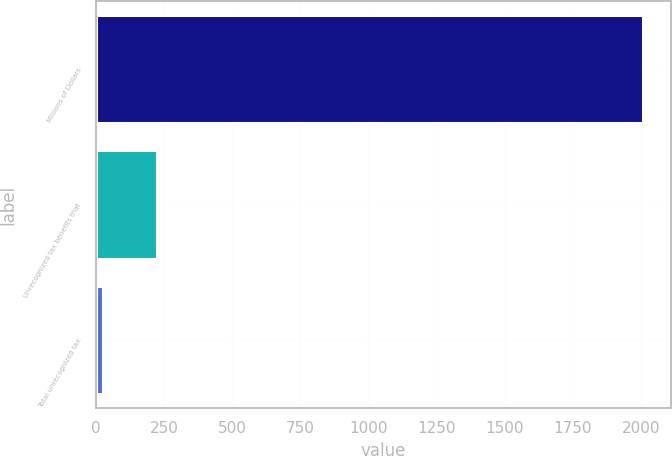Convert chart. <chart><loc_0><loc_0><loc_500><loc_500><bar_chart><fcel>Millions of Dollars<fcel>Unrecognized tax benefits that<fcel>Total unrecognized tax<nl><fcel>2008<fcel>224.2<fcel>26<nl></chart> 